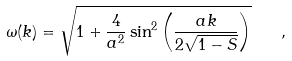Convert formula to latex. <formula><loc_0><loc_0><loc_500><loc_500>\omega ( k ) = \sqrt { 1 + \frac { 4 } { a ^ { 2 } } \sin ^ { 2 } \left ( \frac { a k } { 2 \sqrt { 1 - S } } \right ) } \quad ,</formula> 